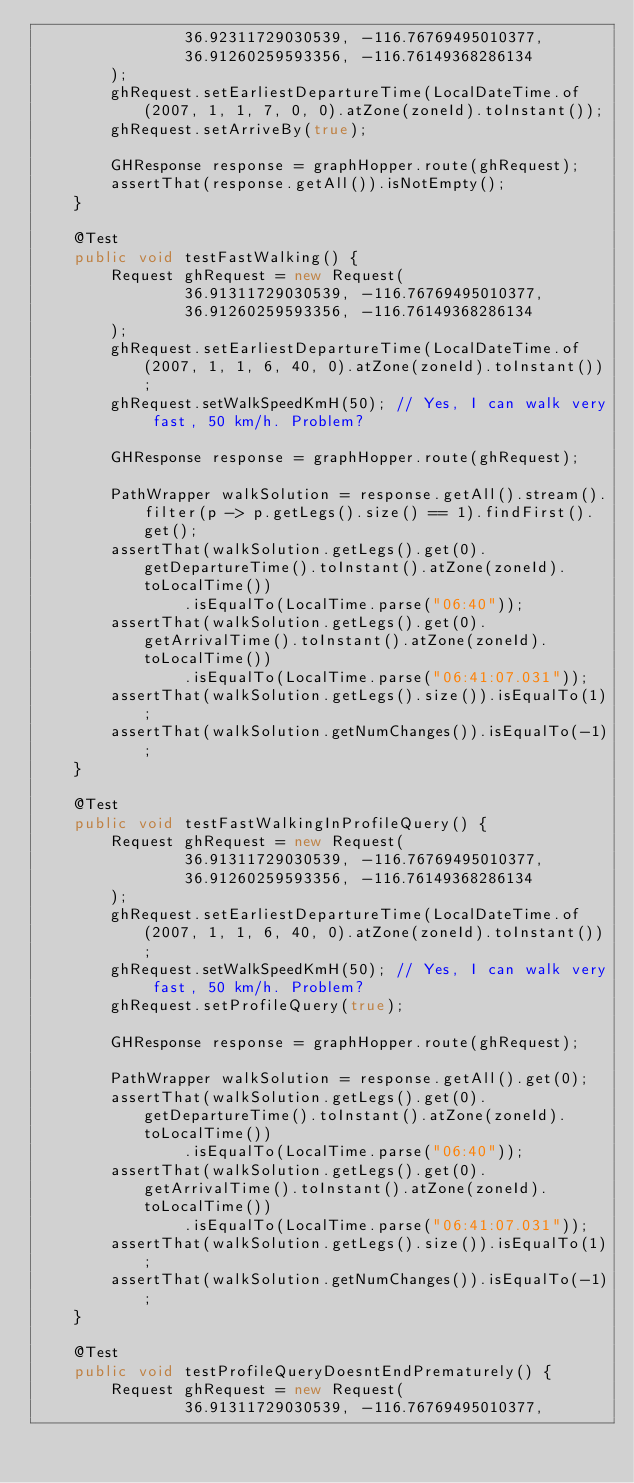<code> <loc_0><loc_0><loc_500><loc_500><_Java_>                36.92311729030539, -116.76769495010377,
                36.91260259593356, -116.76149368286134
        );
        ghRequest.setEarliestDepartureTime(LocalDateTime.of(2007, 1, 1, 7, 0, 0).atZone(zoneId).toInstant());
        ghRequest.setArriveBy(true);

        GHResponse response = graphHopper.route(ghRequest);
        assertThat(response.getAll()).isNotEmpty();
    }

    @Test
    public void testFastWalking() {
        Request ghRequest = new Request(
                36.91311729030539, -116.76769495010377,
                36.91260259593356, -116.76149368286134
        );
        ghRequest.setEarliestDepartureTime(LocalDateTime.of(2007, 1, 1, 6, 40, 0).atZone(zoneId).toInstant());
        ghRequest.setWalkSpeedKmH(50); // Yes, I can walk very fast, 50 km/h. Problem?

        GHResponse response = graphHopper.route(ghRequest);

        PathWrapper walkSolution = response.getAll().stream().filter(p -> p.getLegs().size() == 1).findFirst().get();
        assertThat(walkSolution.getLegs().get(0).getDepartureTime().toInstant().atZone(zoneId).toLocalTime())
                .isEqualTo(LocalTime.parse("06:40"));
        assertThat(walkSolution.getLegs().get(0).getArrivalTime().toInstant().atZone(zoneId).toLocalTime())
                .isEqualTo(LocalTime.parse("06:41:07.031"));
        assertThat(walkSolution.getLegs().size()).isEqualTo(1);
        assertThat(walkSolution.getNumChanges()).isEqualTo(-1);
    }

    @Test
    public void testFastWalkingInProfileQuery() {
        Request ghRequest = new Request(
                36.91311729030539, -116.76769495010377,
                36.91260259593356, -116.76149368286134
        );
        ghRequest.setEarliestDepartureTime(LocalDateTime.of(2007, 1, 1, 6, 40, 0).atZone(zoneId).toInstant());
        ghRequest.setWalkSpeedKmH(50); // Yes, I can walk very fast, 50 km/h. Problem?
        ghRequest.setProfileQuery(true);

        GHResponse response = graphHopper.route(ghRequest);

        PathWrapper walkSolution = response.getAll().get(0);
        assertThat(walkSolution.getLegs().get(0).getDepartureTime().toInstant().atZone(zoneId).toLocalTime())
                .isEqualTo(LocalTime.parse("06:40"));
        assertThat(walkSolution.getLegs().get(0).getArrivalTime().toInstant().atZone(zoneId).toLocalTime())
                .isEqualTo(LocalTime.parse("06:41:07.031"));
        assertThat(walkSolution.getLegs().size()).isEqualTo(1);
        assertThat(walkSolution.getNumChanges()).isEqualTo(-1);
    }

    @Test
    public void testProfileQueryDoesntEndPrematurely() {
        Request ghRequest = new Request(
                36.91311729030539, -116.76769495010377,</code> 